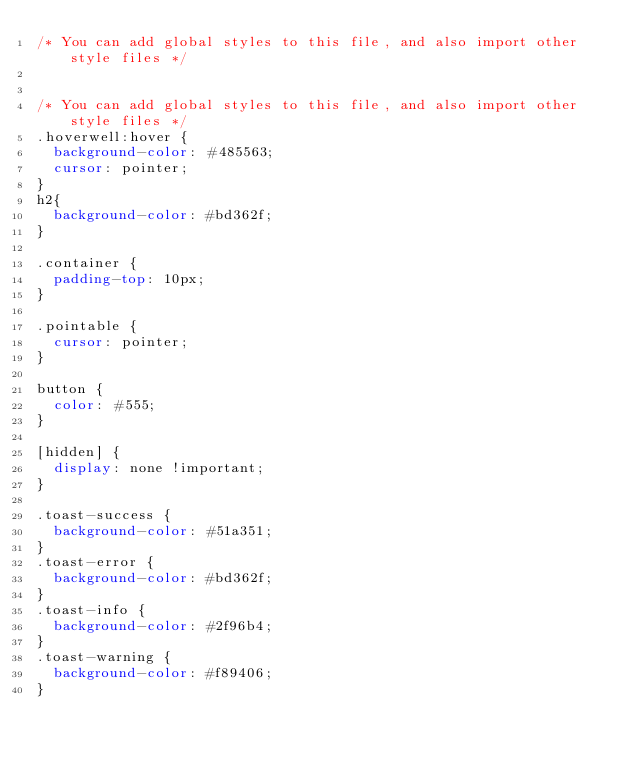Convert code to text. <code><loc_0><loc_0><loc_500><loc_500><_CSS_>/* You can add global styles to this file, and also import other style files */


/* You can add global styles to this file, and also import other style files */
.hoverwell:hover {
  background-color: #485563;
  cursor: pointer;
}
h2{
  background-color: #bd362f;
}

.container {
  padding-top: 10px;
}

.pointable {
  cursor: pointer;
}

button {
  color: #555;
}

[hidden] {
  display: none !important;
}

.toast-success {
  background-color: #51a351;
}
.toast-error {
  background-color: #bd362f;
}
.toast-info {
  background-color: #2f96b4;
}
.toast-warning {
  background-color: #f89406;
}
</code> 